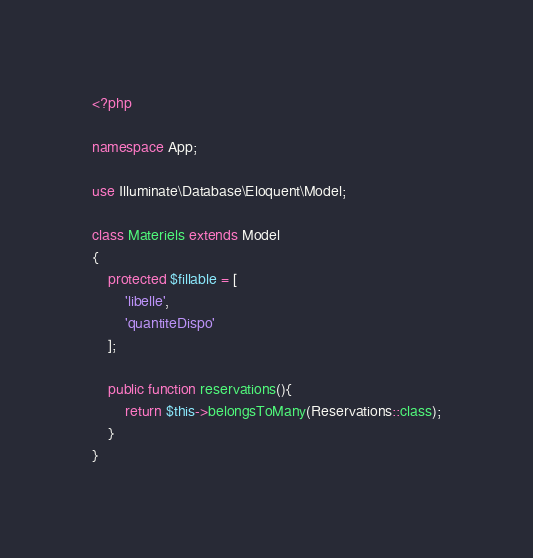<code> <loc_0><loc_0><loc_500><loc_500><_PHP_><?php

namespace App;

use Illuminate\Database\Eloquent\Model;

class Materiels extends Model
{
    protected $fillable = [
        'libelle',
        'quantiteDispo'
    ];

    public function reservations(){
        return $this->belongsToMany(Reservations::class);
    }
}
</code> 